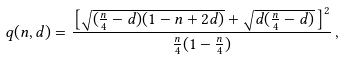<formula> <loc_0><loc_0><loc_500><loc_500>q ( n , d ) = \frac { \left [ \sqrt { ( \frac { n } { 4 } - d ) ( 1 - n + 2 d ) } + \sqrt { d ( \frac { n } { 4 } - d ) } \, \right ] ^ { 2 } } { \frac { n } { 4 } ( 1 - \frac { n } { 4 } ) } \, ,</formula> 